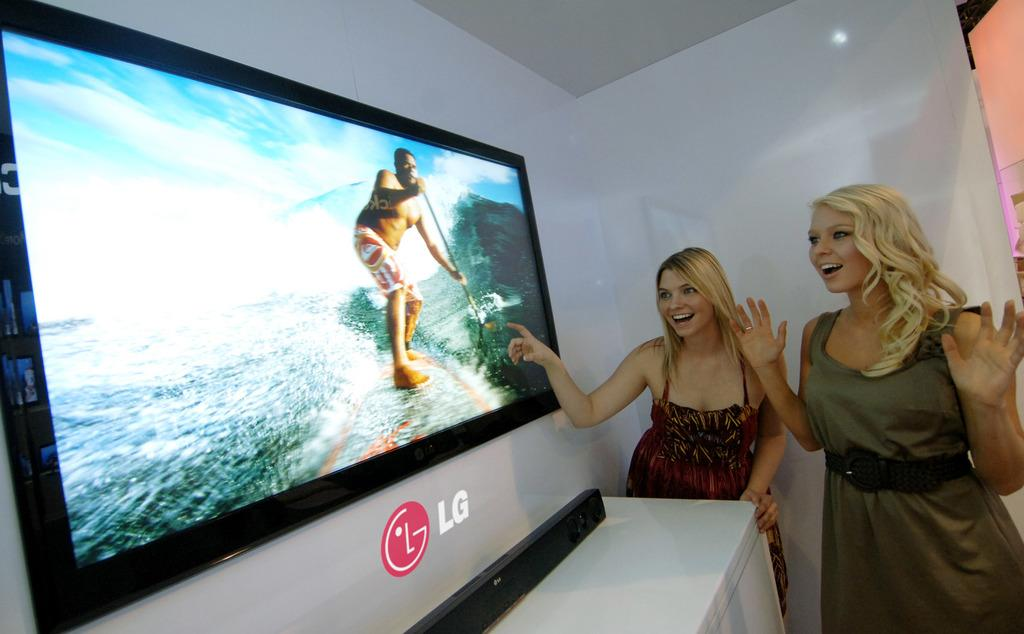<image>
Relay a brief, clear account of the picture shown. Two woman stand close to a large LG television with their arms up. 